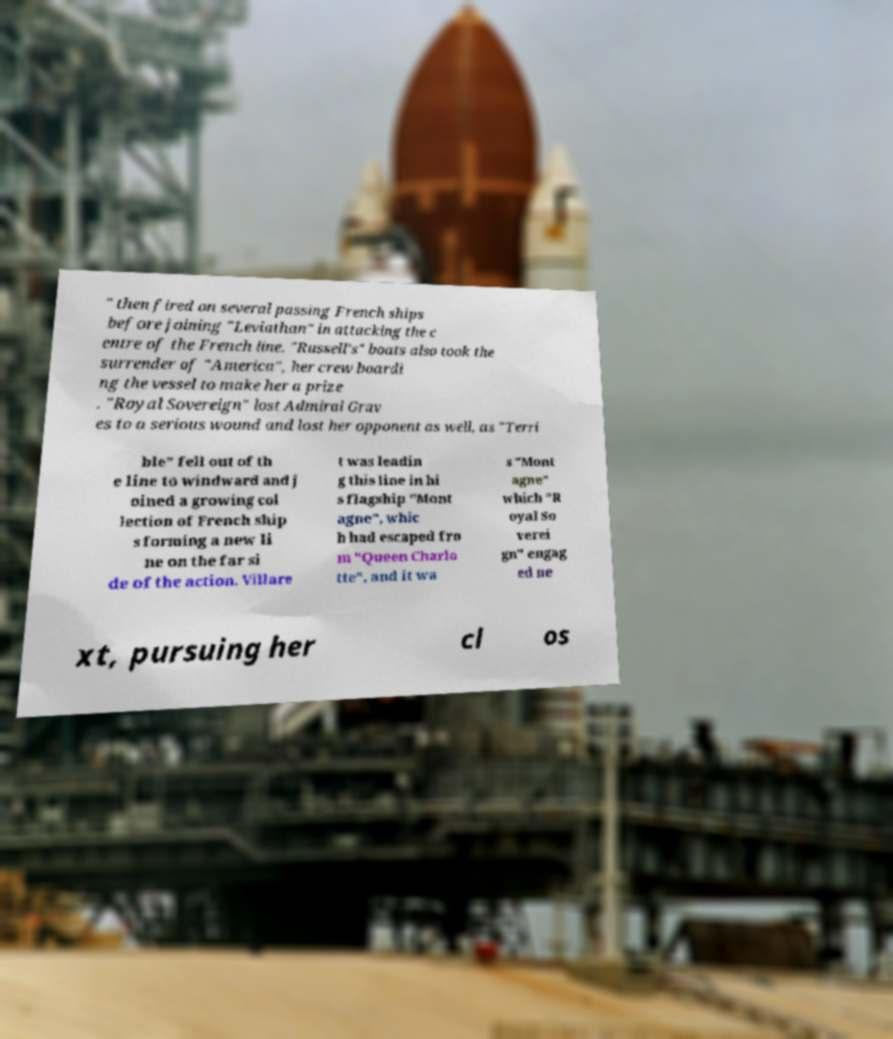What messages or text are displayed in this image? I need them in a readable, typed format. " then fired on several passing French ships before joining "Leviathan" in attacking the c entre of the French line. "Russell's" boats also took the surrender of "America", her crew boardi ng the vessel to make her a prize . "Royal Sovereign" lost Admiral Grav es to a serious wound and lost her opponent as well, as "Terri ble" fell out of th e line to windward and j oined a growing col lection of French ship s forming a new li ne on the far si de of the action. Villare t was leadin g this line in hi s flagship "Mont agne", whic h had escaped fro m "Queen Charlo tte", and it wa s "Mont agne" which "R oyal So verei gn" engag ed ne xt, pursuing her cl os 